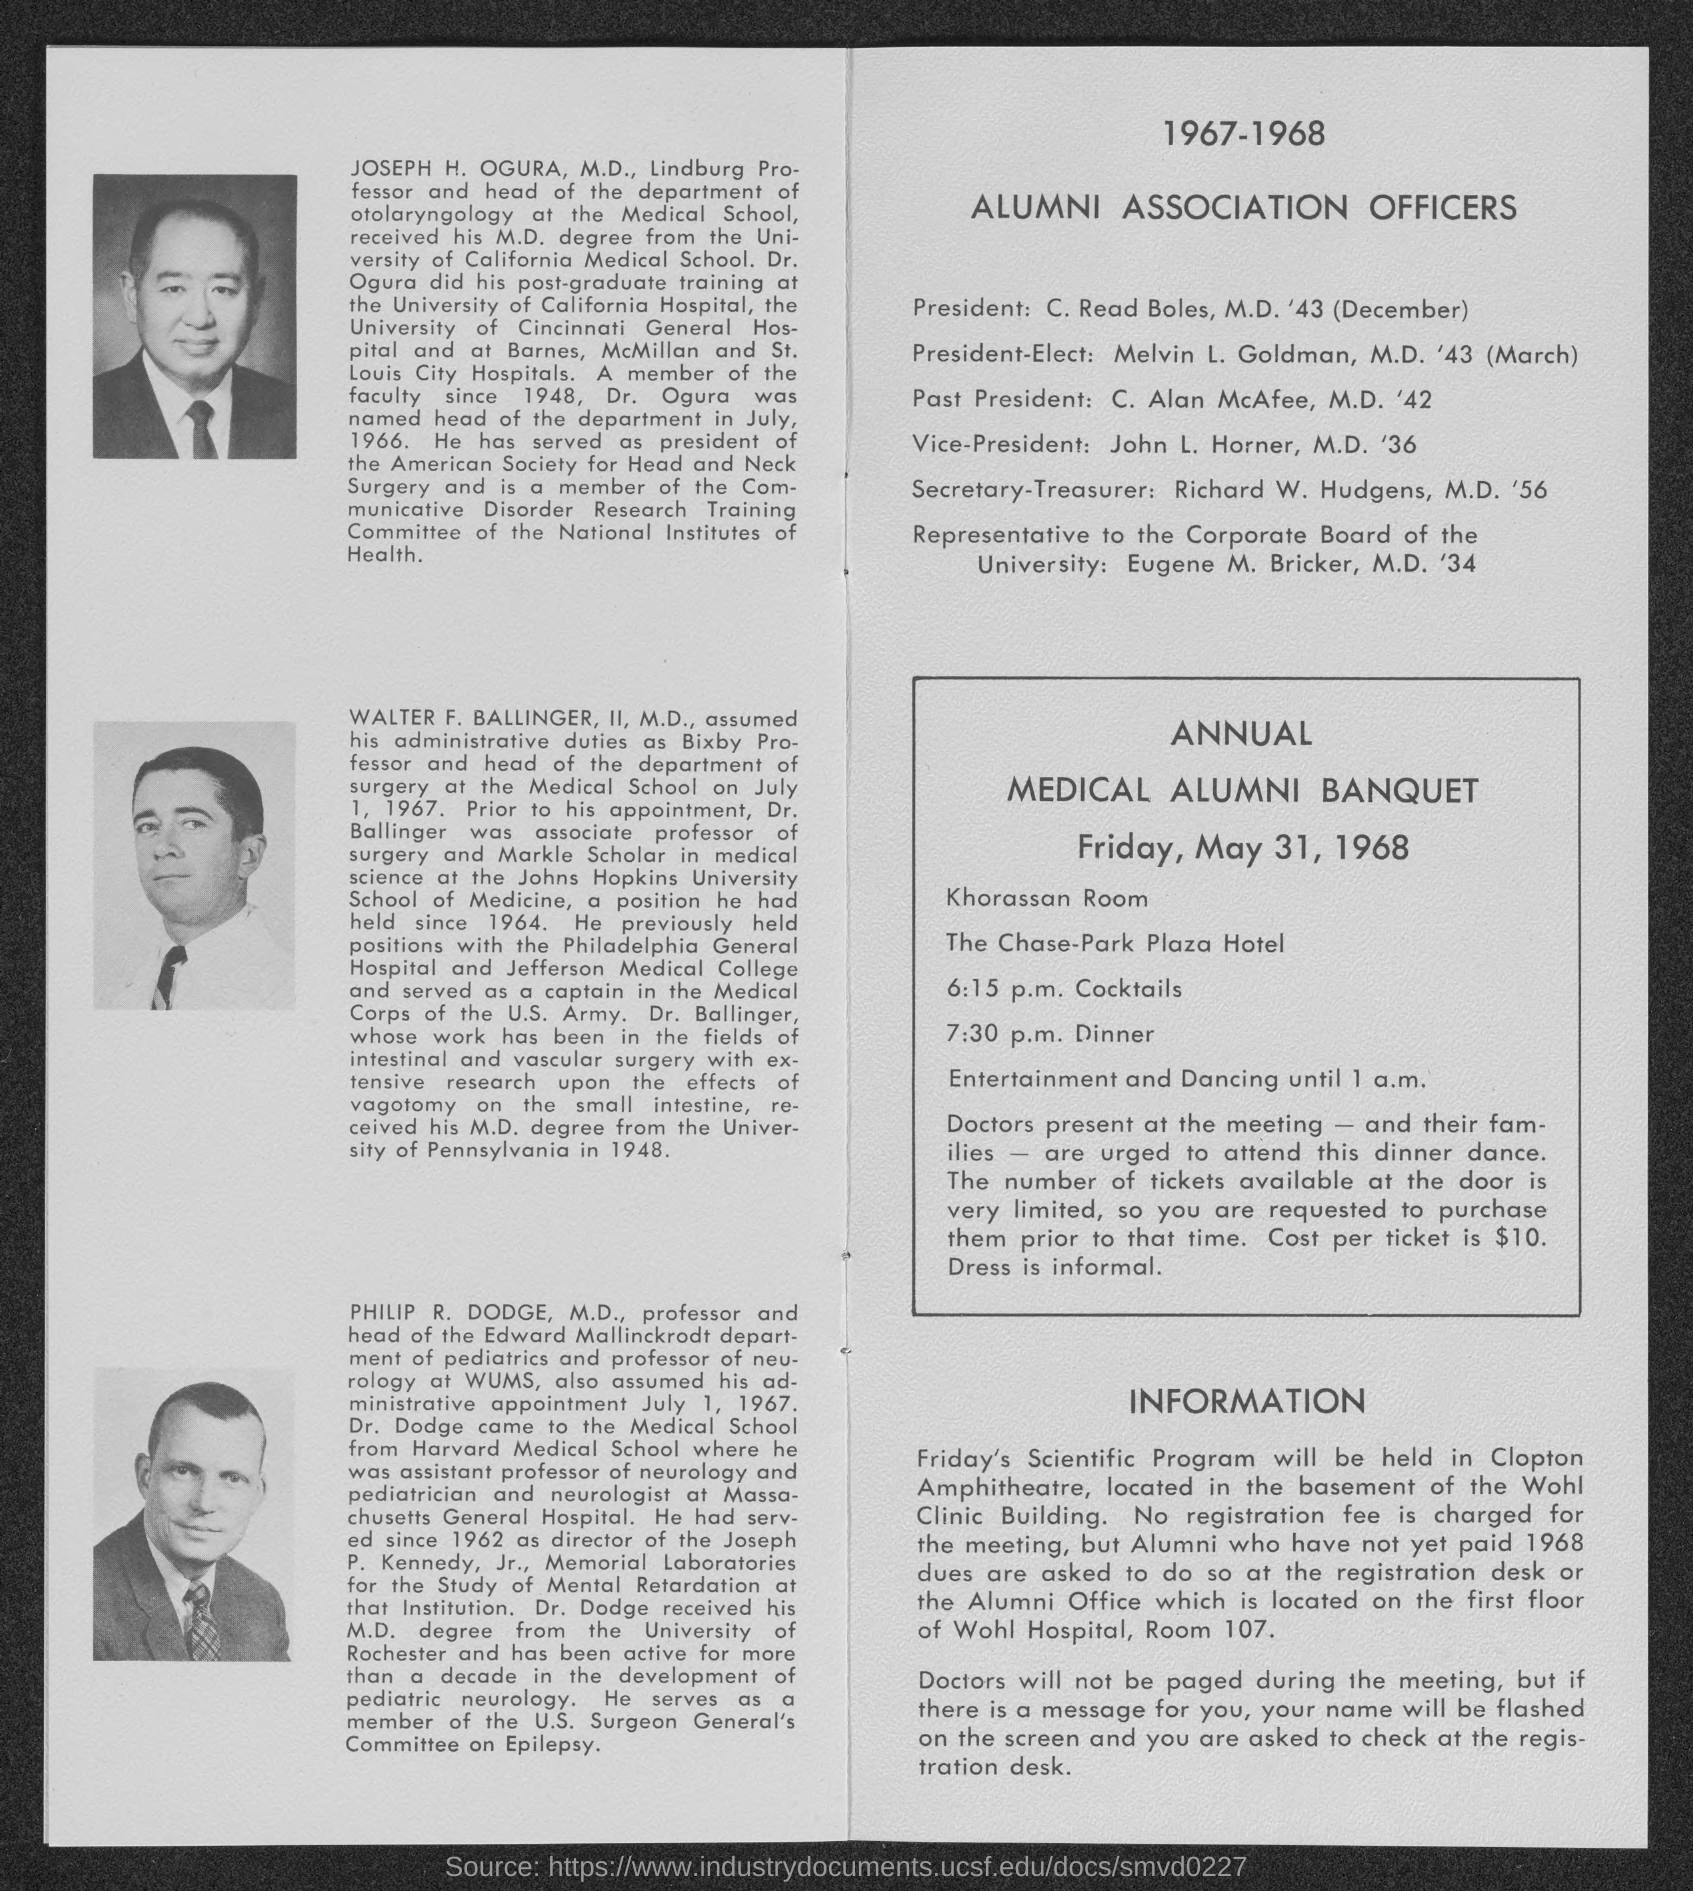What is the name of the representative to the corporate board of the university ?
Offer a terse response. Eugene M. Bricker, M.D. 